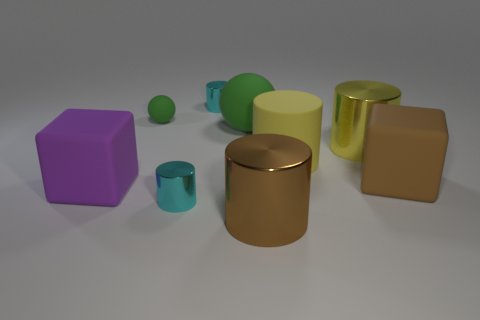Subtract all large yellow metallic cylinders. How many cylinders are left? 4 Subtract all brown cylinders. How many cylinders are left? 4 Add 1 large rubber cylinders. How many objects exist? 10 Subtract all green cylinders. Subtract all purple spheres. How many cylinders are left? 5 Subtract all cylinders. How many objects are left? 4 Add 8 green balls. How many green balls are left? 10 Add 3 green rubber cubes. How many green rubber cubes exist? 3 Subtract 0 gray blocks. How many objects are left? 9 Subtract all small gray rubber blocks. Subtract all small matte spheres. How many objects are left? 8 